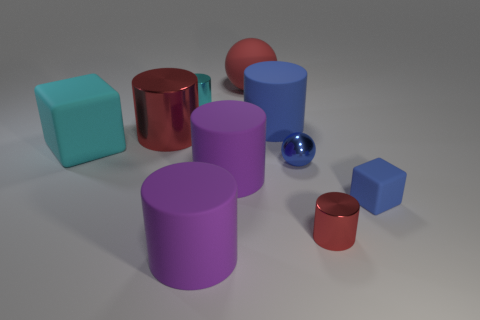Subtract all blue cylinders. How many cylinders are left? 5 Subtract all blue cylinders. How many cylinders are left? 5 Subtract all balls. How many objects are left? 8 Subtract 0 brown spheres. How many objects are left? 10 Subtract 4 cylinders. How many cylinders are left? 2 Subtract all brown blocks. Subtract all blue cylinders. How many blocks are left? 2 Subtract all blue cylinders. How many yellow blocks are left? 0 Subtract all small cylinders. Subtract all red rubber things. How many objects are left? 7 Add 2 cyan metallic objects. How many cyan metallic objects are left? 3 Add 2 large matte objects. How many large matte objects exist? 7 